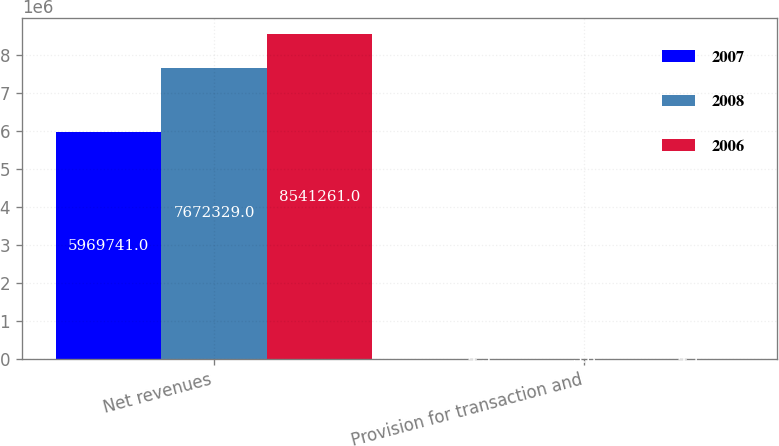<chart> <loc_0><loc_0><loc_500><loc_500><stacked_bar_chart><ecel><fcel>Net revenues<fcel>Provision for transaction and<nl><fcel>2007<fcel>5.96974e+06<fcel>4.5<nl><fcel>2008<fcel>7.67233e+06<fcel>3.8<nl><fcel>2006<fcel>8.54126e+06<fcel>4.1<nl></chart> 